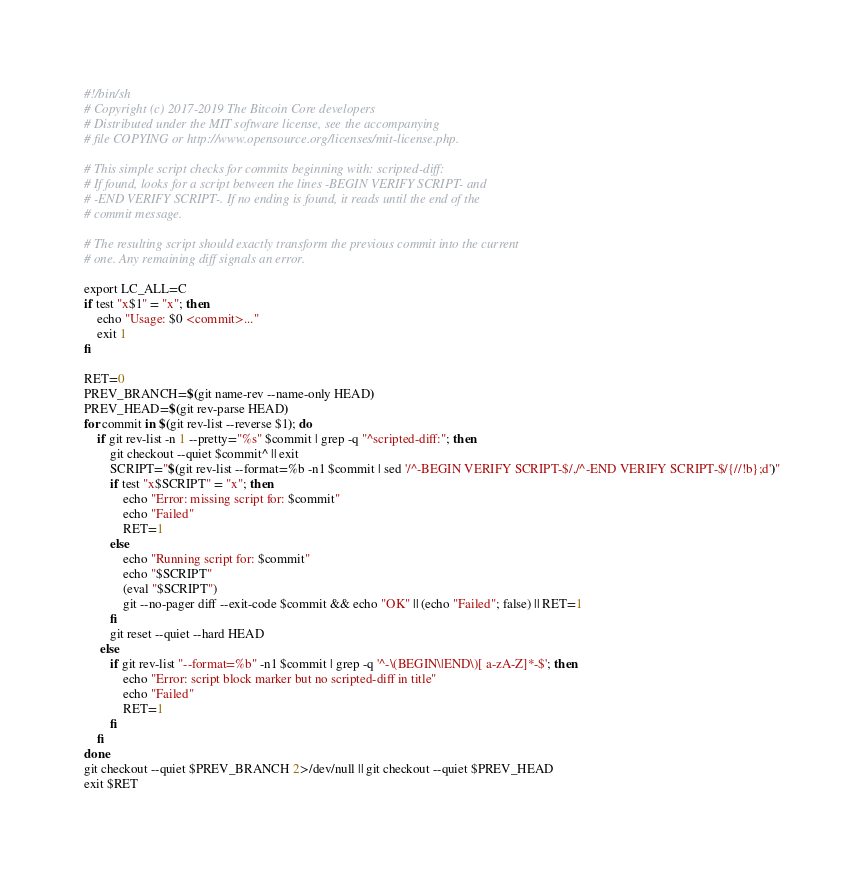<code> <loc_0><loc_0><loc_500><loc_500><_Bash_>#!/bin/sh
# Copyright (c) 2017-2019 The Bitcoin Core developers
# Distributed under the MIT software license, see the accompanying
# file COPYING or http://www.opensource.org/licenses/mit-license.php.

# This simple script checks for commits beginning with: scripted-diff:
# If found, looks for a script between the lines -BEGIN VERIFY SCRIPT- and
# -END VERIFY SCRIPT-. If no ending is found, it reads until the end of the
# commit message.

# The resulting script should exactly transform the previous commit into the current
# one. Any remaining diff signals an error.

export LC_ALL=C
if test "x$1" = "x"; then
    echo "Usage: $0 <commit>..."
    exit 1
fi

RET=0
PREV_BRANCH=$(git name-rev --name-only HEAD)
PREV_HEAD=$(git rev-parse HEAD)
for commit in $(git rev-list --reverse $1); do
    if git rev-list -n 1 --pretty="%s" $commit | grep -q "^scripted-diff:"; then
        git checkout --quiet $commit^ || exit
        SCRIPT="$(git rev-list --format=%b -n1 $commit | sed '/^-BEGIN VERIFY SCRIPT-$/,/^-END VERIFY SCRIPT-$/{//!b};d')"
        if test "x$SCRIPT" = "x"; then
            echo "Error: missing script for: $commit"
            echo "Failed"
            RET=1
        else
            echo "Running script for: $commit"
            echo "$SCRIPT"
            (eval "$SCRIPT")
            git --no-pager diff --exit-code $commit && echo "OK" || (echo "Failed"; false) || RET=1
        fi
        git reset --quiet --hard HEAD
     else
        if git rev-list "--format=%b" -n1 $commit | grep -q '^-\(BEGIN\|END\)[ a-zA-Z]*-$'; then
            echo "Error: script block marker but no scripted-diff in title"
            echo "Failed"
            RET=1
        fi
    fi
done
git checkout --quiet $PREV_BRANCH 2>/dev/null || git checkout --quiet $PREV_HEAD
exit $RET
</code> 